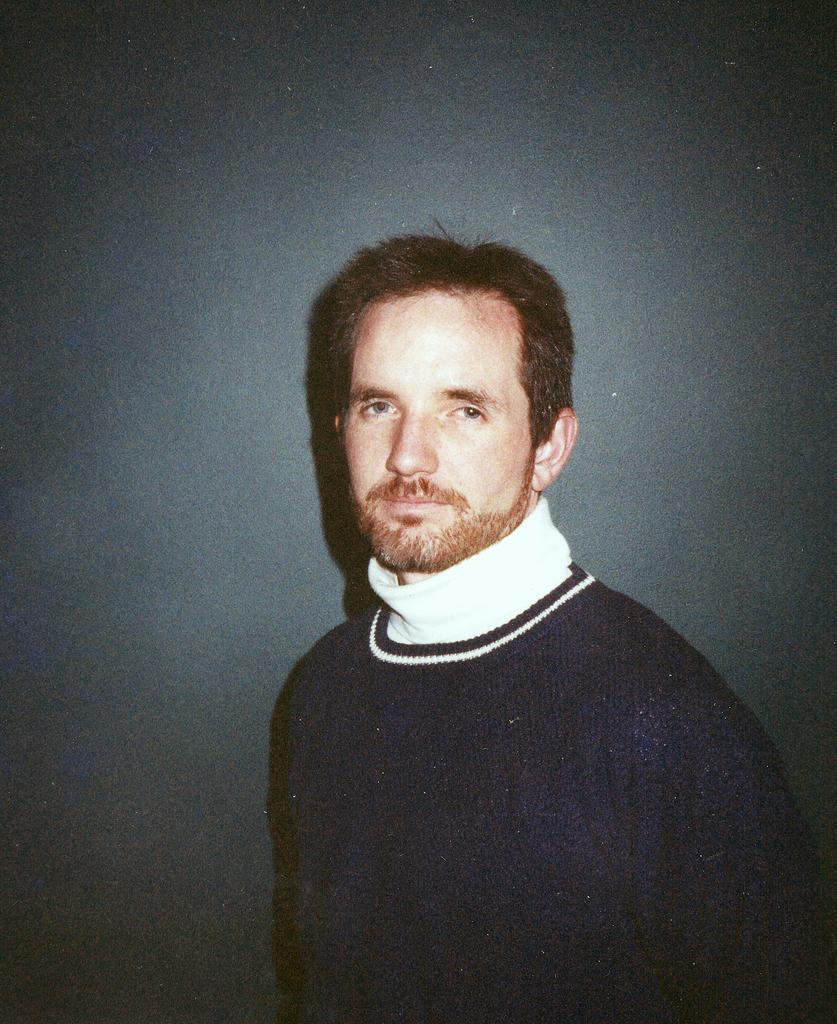Who is present in the image? There is a man in the image. What is the man doing in the image? The man is standing in the image. What can be seen in the background of the image? There is a wall in the image. What type of animals can be seen at the zoo in the image? There is no zoo present in the image, so it's not possible to determine what, if any, animals might be seen. 